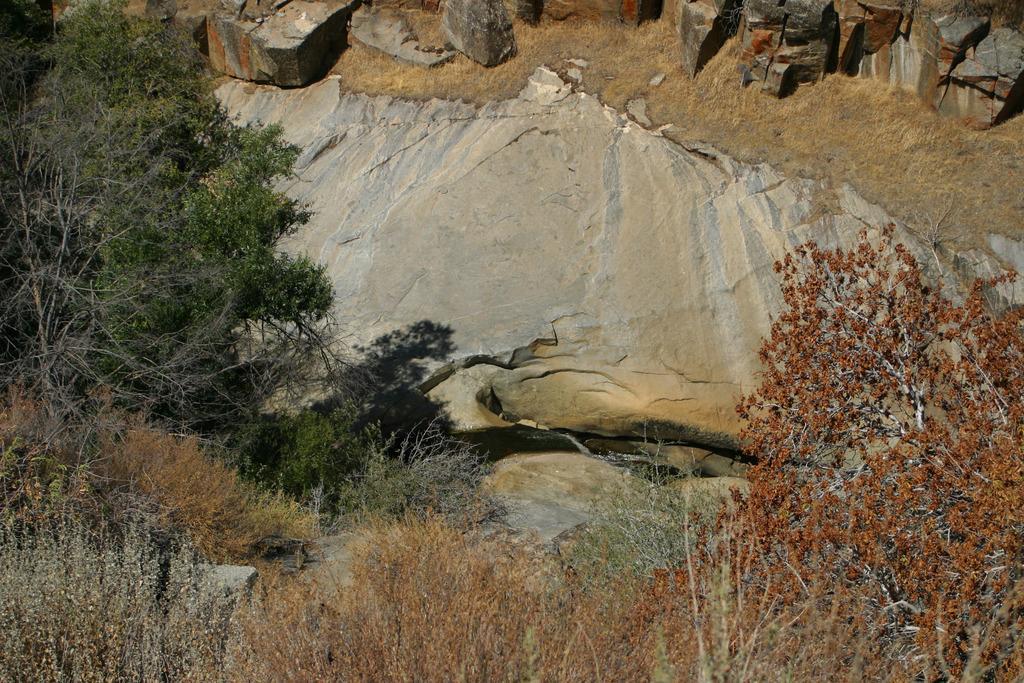How would you summarize this image in a sentence or two? In this picture I can observe some plants and trees. I can observe some water in the middle of the picture. In the top of the picture I can observe some rocks. 